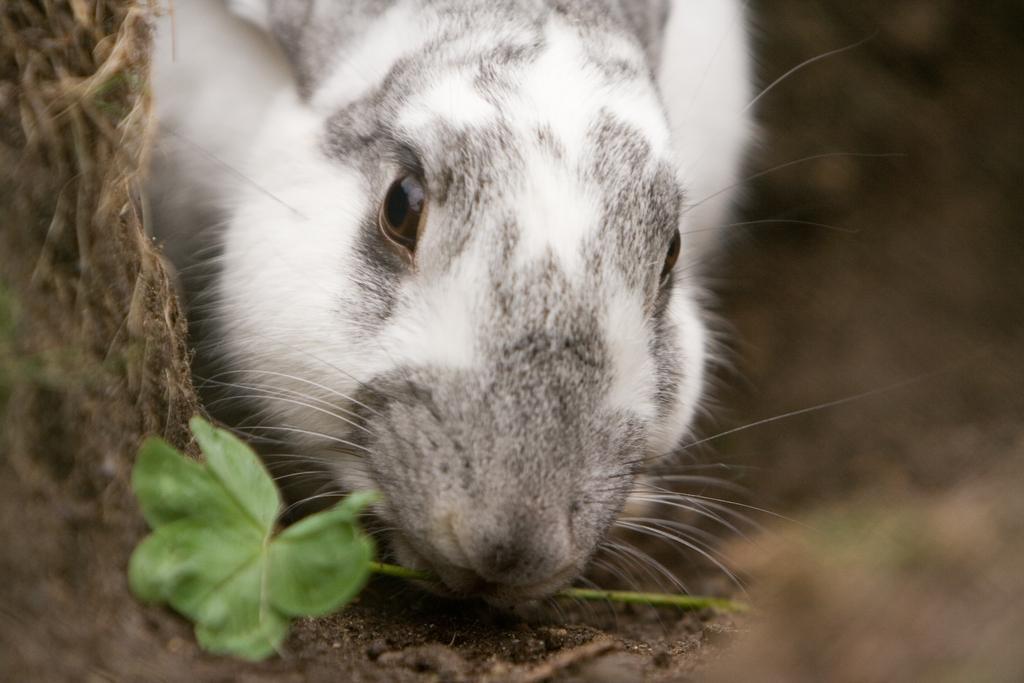Please provide a concise description of this image. In this image, we can see an animal with a leaf in its mouth. We can also see the ground. 